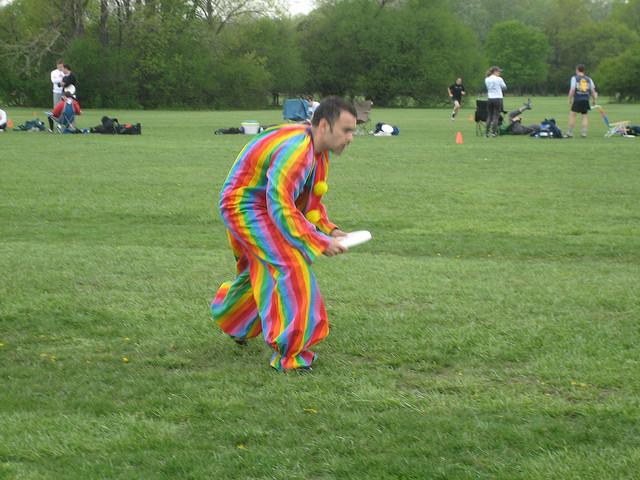What are the people doing in the photograph?
Quick response, please. Frisbee. What colorful object is the man carrying?
Keep it brief. Frisbee. What is the man dressed as?
Quick response, please. Clown. What color is the frisbee the man is holding?
Short answer required. White. Is the man wearing shorts?
Quick response, please. No. What looks like a flag?
Quick response, please. Man's clothes. What are hanging in his neck?
Quick response, please. Balls. 